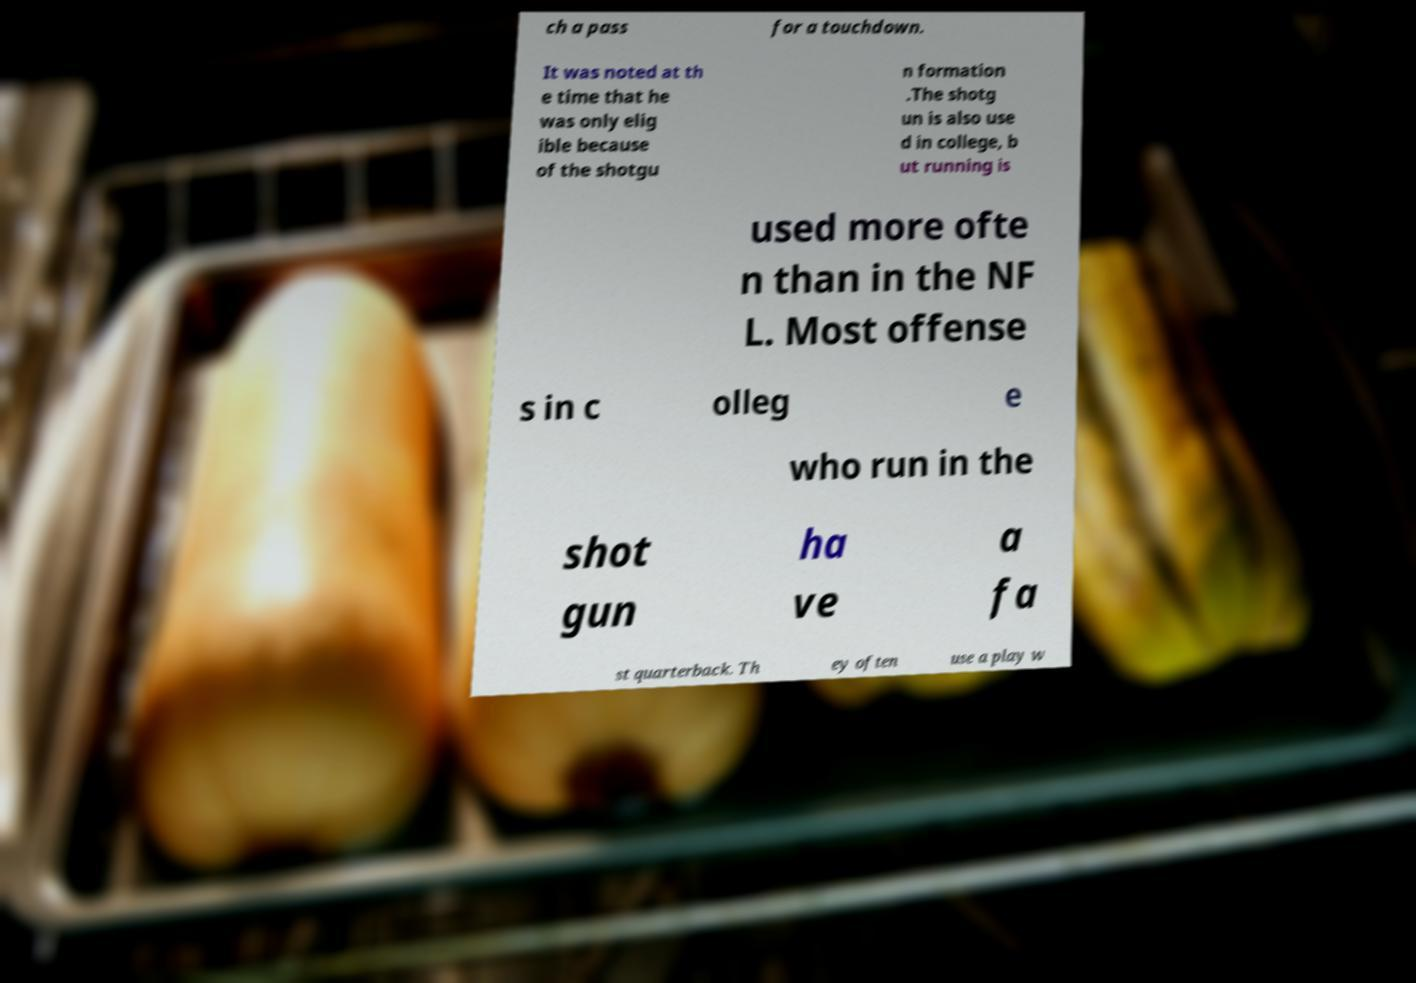I need the written content from this picture converted into text. Can you do that? ch a pass for a touchdown. It was noted at th e time that he was only elig ible because of the shotgu n formation .The shotg un is also use d in college, b ut running is used more ofte n than in the NF L. Most offense s in c olleg e who run in the shot gun ha ve a fa st quarterback. Th ey often use a play w 